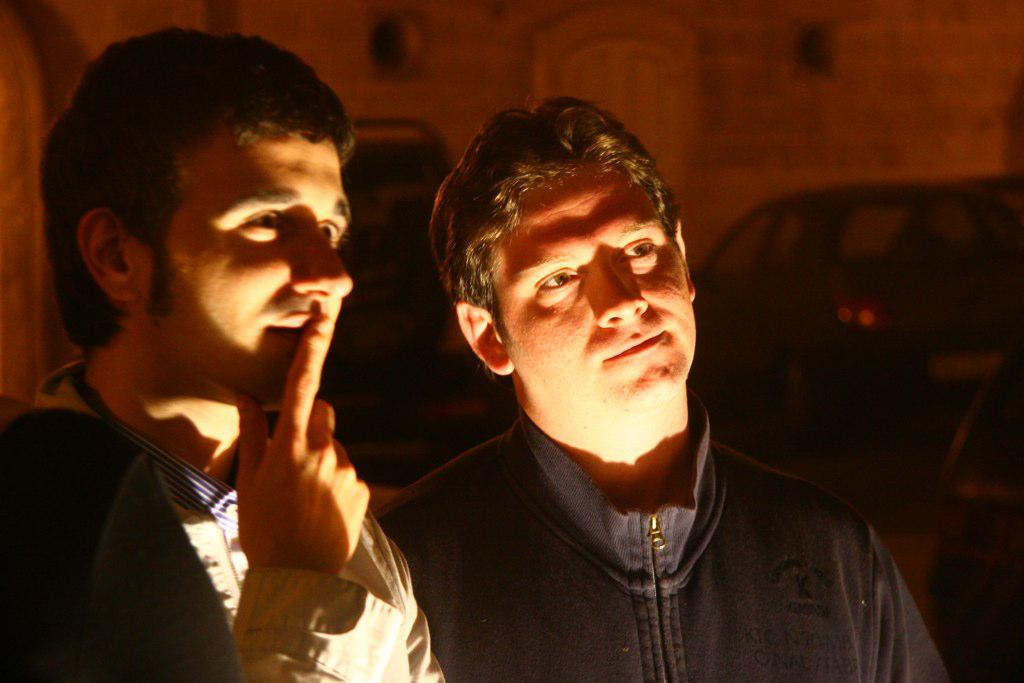How many people are present in the image? There are two persons standing in the image. What else can be seen in the image besides the people? Vehicles are visible in the image. Are there any objects attached to the wall in the image? Yes, there are objects attached to the wall in the image. What impulse caused the downtown area to suddenly fall in the image? There is no downtown area or any indication of a sudden fall in the image. 